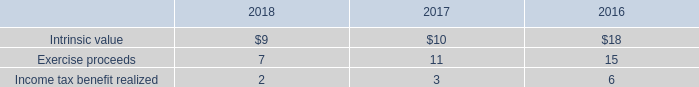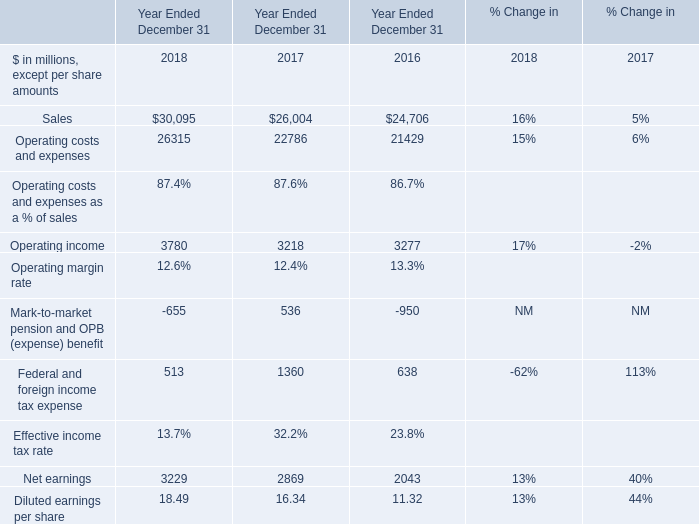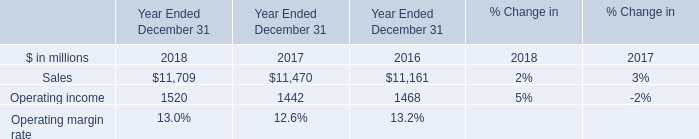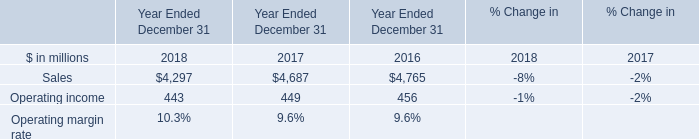What is the total amount of Sales of Year Ended December 31 2018, and Operating income of Year Ended December 31 2016 ? 
Computations: (11709.0 + 3277.0)
Answer: 14986.0. 